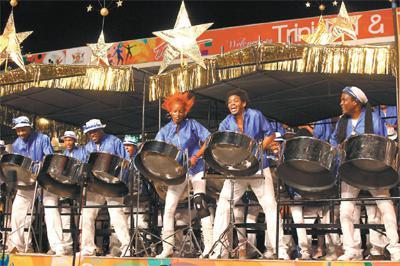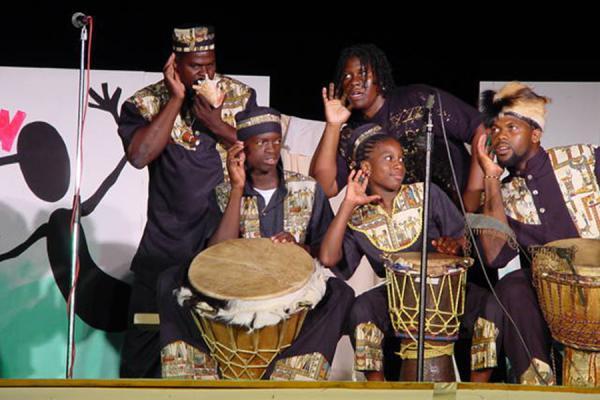The first image is the image on the left, the second image is the image on the right. Given the left and right images, does the statement "The right image shows a line of standing drummers in shiny fedora hats, with silver drums on stands in front of them." hold true? Answer yes or no. No. The first image is the image on the left, the second image is the image on the right. Evaluate the accuracy of this statement regarding the images: "In one image, every musician is wearing a hat.". Is it true? Answer yes or no. No. 